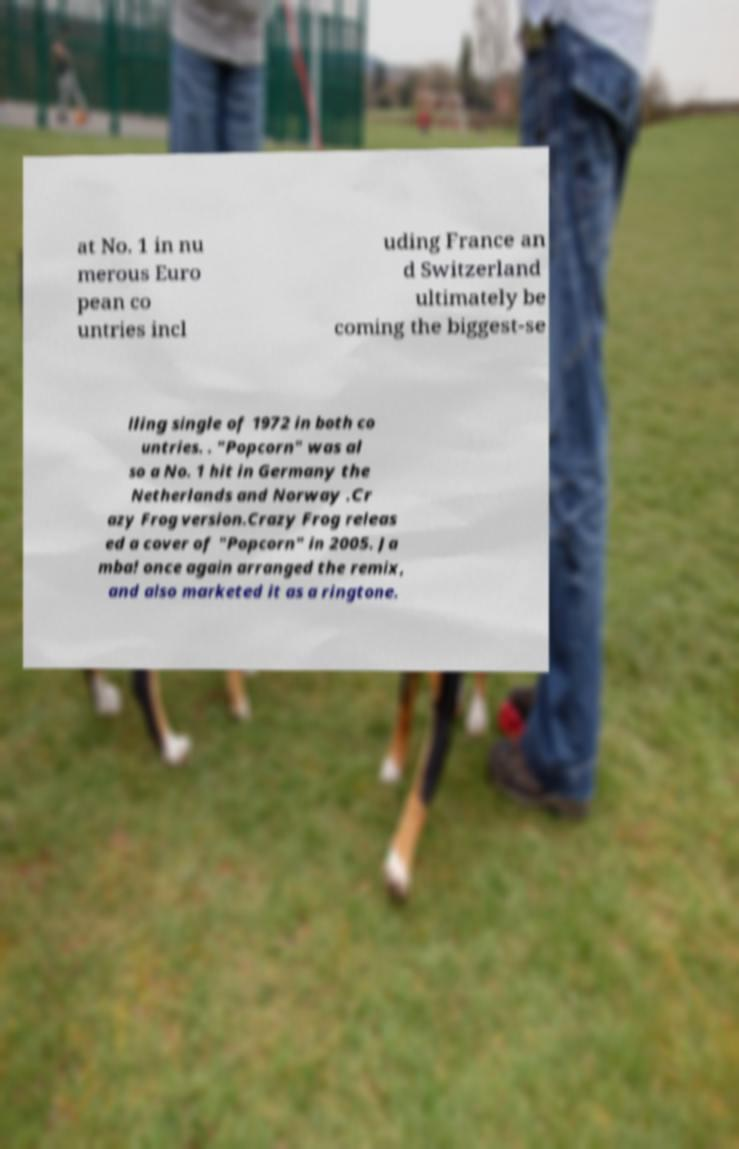Can you read and provide the text displayed in the image?This photo seems to have some interesting text. Can you extract and type it out for me? at No. 1 in nu merous Euro pean co untries incl uding France an d Switzerland ultimately be coming the biggest-se lling single of 1972 in both co untries. . "Popcorn" was al so a No. 1 hit in Germany the Netherlands and Norway .Cr azy Frog version.Crazy Frog releas ed a cover of "Popcorn" in 2005. Ja mba! once again arranged the remix, and also marketed it as a ringtone. 